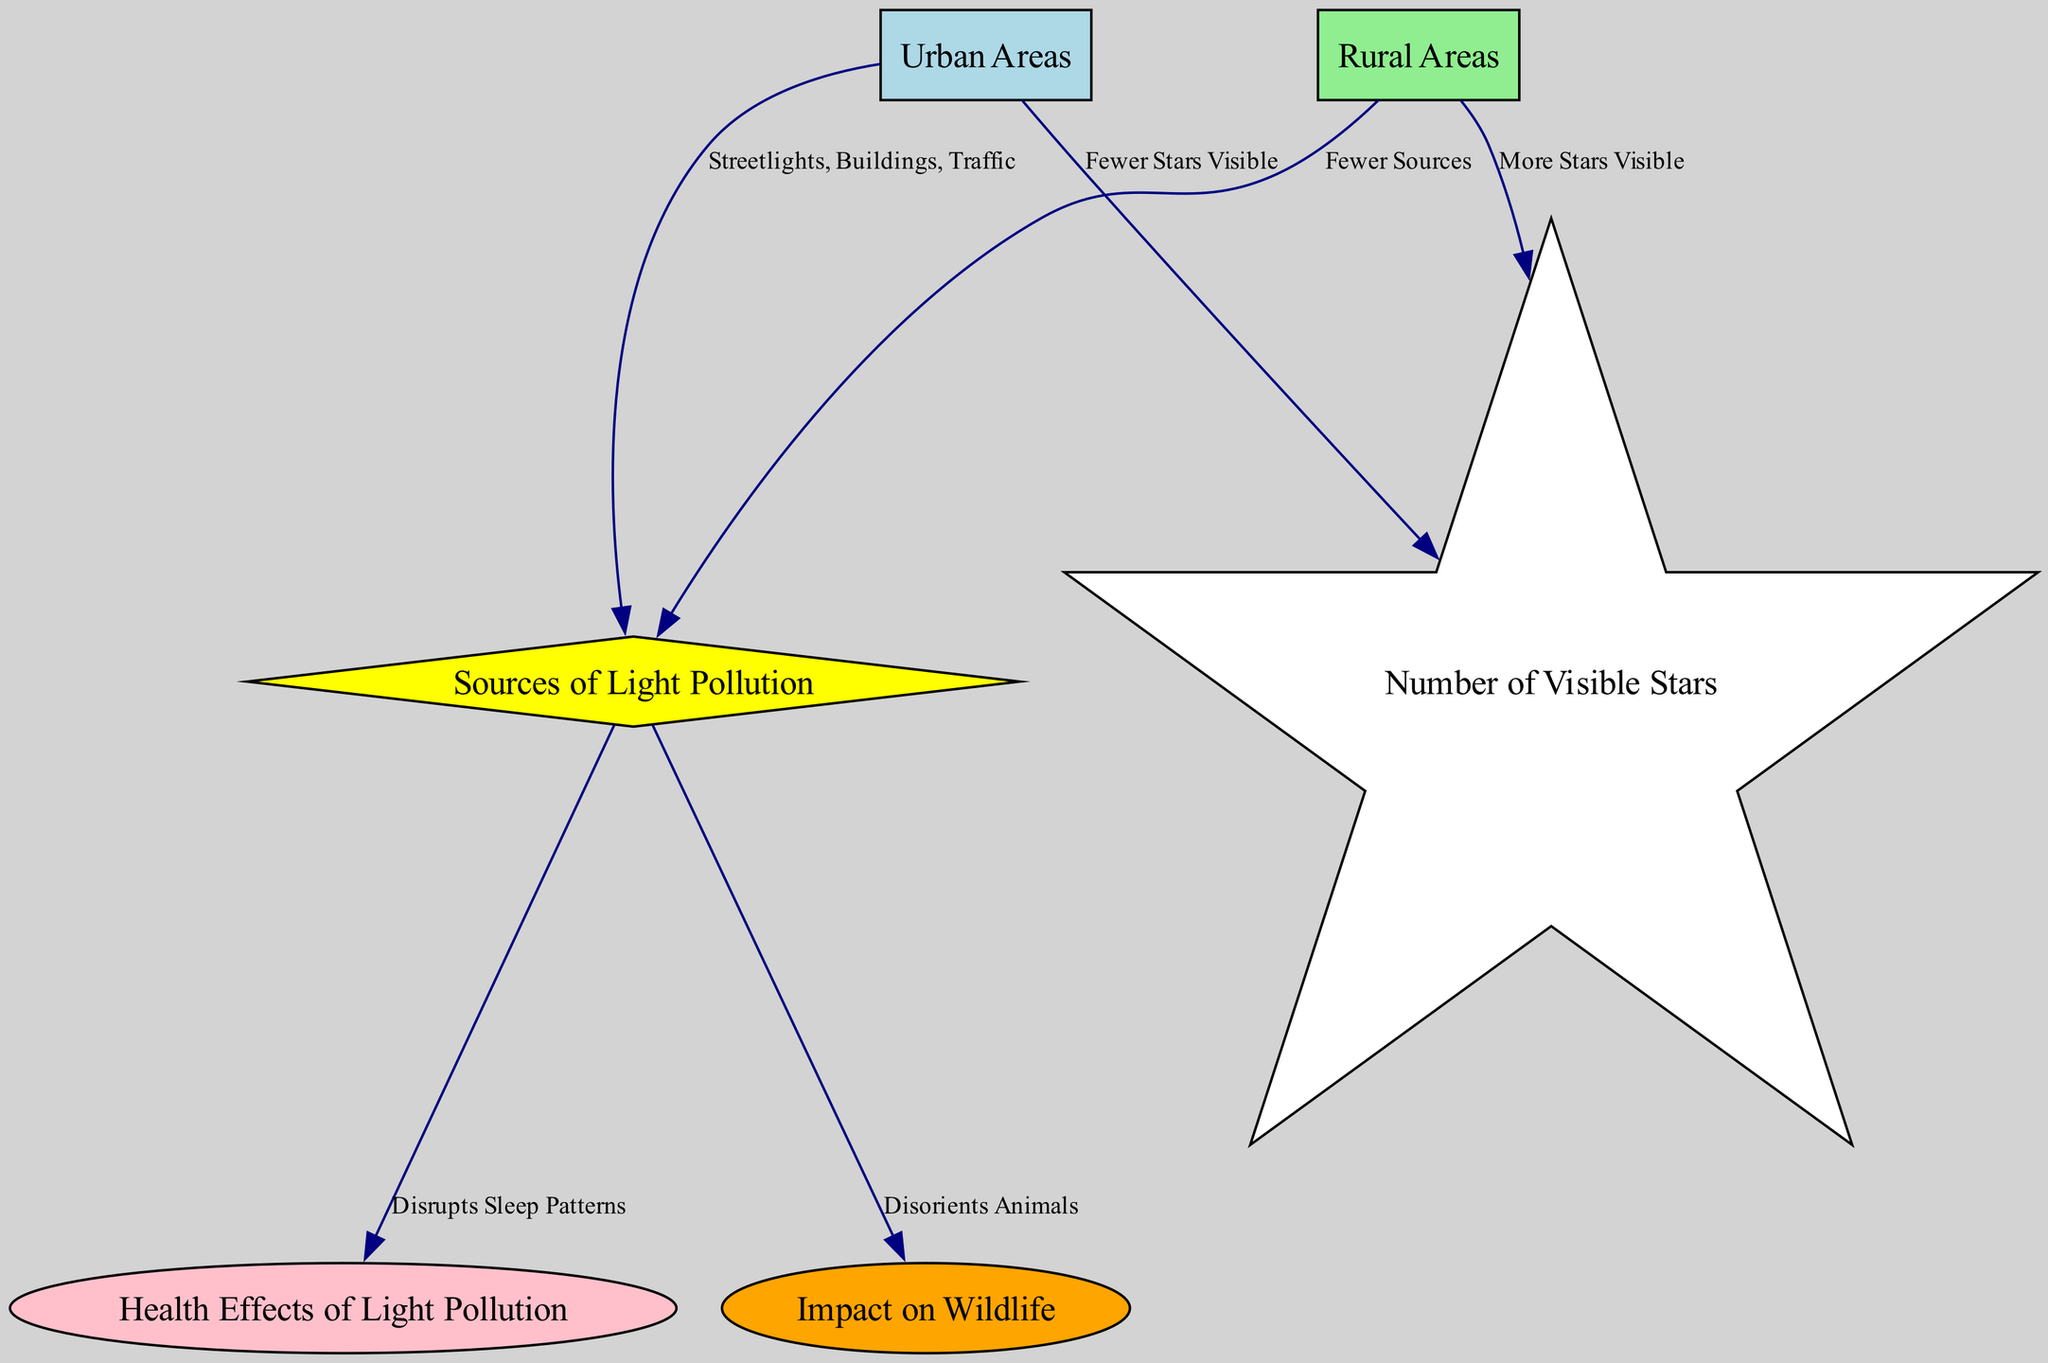What are the two main areas compared in the diagram? The diagram distinguishes between two types of areas: "Urban Areas" and "Rural Areas." These labels are explicitly mentioned as nodes in the diagram, clearly indicating these areas are the focus of comparison regarding light pollution and star visibility.
Answer: Urban Areas and Rural Areas What is the relationship between urban areas and the sources of light pollution? The diagram shows an edge from "Urban Areas" to "Sources of Light Pollution," indicating a direct connection. The label "Streetlights, Buildings, Traffic" describes the types of light pollution sources prevalent in urban areas.
Answer: Streetlights, Buildings, Traffic How many visible stars are associated with rural areas? The diagram indicates a relationship between "Rural Areas" and "Number of Visible Stars," with the label specifying that there are "More Stars Visible" in rural areas. This direct association provides the numerical understanding of visibility in comparison to urban areas.
Answer: More Stars Visible What health effects are linked to sources of light pollution? An edge from "Sources of Light Pollution" to "Health Effects of Light Pollution" is visible in the diagram, with the label stating that it "Disrupts Sleep Patterns." This reveals a direct consequence of light pollution affecting health.
Answer: Disrupts Sleep Patterns What impact does light pollution have on wildlife as depicted in the diagram? The diagram shows an edge from "Sources of Light Pollution" to "Impact on Wildlife," with the label stating "Disorients Animals." This signifies a clear connection between light pollution sources and their detrimental effects on wildlife.
Answer: Disorients Animals Which area has fewer sources of light pollution? According to the diagram, "Rural Areas" have an edge leading to "Sources of Light Pollution," marked with "Fewer Sources." This indicates that rural areas experience less light pollution compared to urban settings.
Answer: Fewer Sources What is the contrasting visibility of stars between urban and rural areas? The diagram presents relationships where "Urban Areas" have "Fewer Stars Visible" and "Rural Areas" have "More Stars Visible." This contrast highlights the significant difference in star visibility owing to the surrounding light pollution levels.
Answer: Fewer Stars Visible vs. More Stars Visible How does light pollution affect the health of residents in urban areas? The edge from "Sources of Light Pollution" leads to "Health Effects of Light Pollution," which states "Disrupts Sleep Patterns." This shows that the light pollution primarily found in urban areas has direct adverse health implications for residents.
Answer: Disrupts Sleep Patterns 